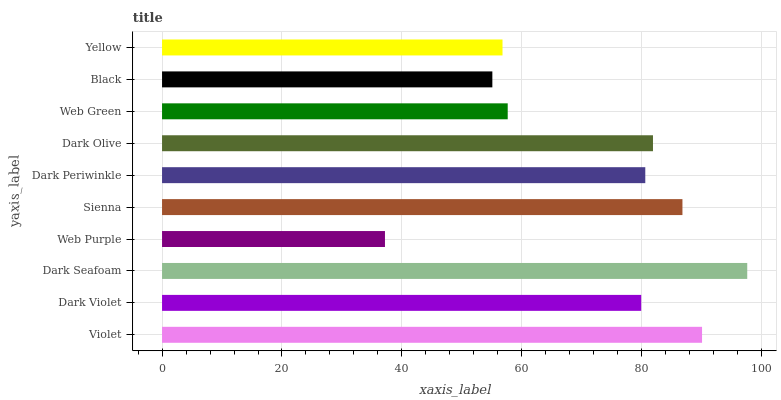Is Web Purple the minimum?
Answer yes or no. Yes. Is Dark Seafoam the maximum?
Answer yes or no. Yes. Is Dark Violet the minimum?
Answer yes or no. No. Is Dark Violet the maximum?
Answer yes or no. No. Is Violet greater than Dark Violet?
Answer yes or no. Yes. Is Dark Violet less than Violet?
Answer yes or no. Yes. Is Dark Violet greater than Violet?
Answer yes or no. No. Is Violet less than Dark Violet?
Answer yes or no. No. Is Dark Periwinkle the high median?
Answer yes or no. Yes. Is Dark Violet the low median?
Answer yes or no. Yes. Is Violet the high median?
Answer yes or no. No. Is Yellow the low median?
Answer yes or no. No. 